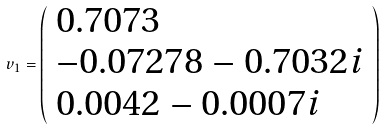<formula> <loc_0><loc_0><loc_500><loc_500>v _ { 1 } = { \left ( \begin{array} { l } { 0 . 7 0 7 3 } \\ { - 0 . 0 7 2 7 8 - 0 . 7 0 3 2 i } \\ { 0 . 0 0 4 2 - 0 . 0 0 0 7 i } \end{array} \right ) }</formula> 